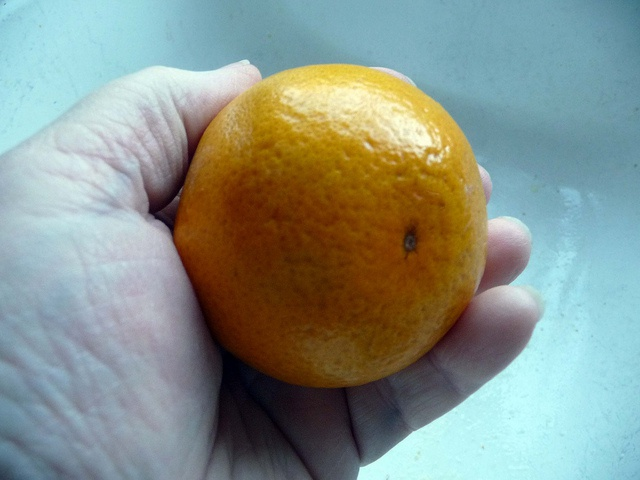Describe the objects in this image and their specific colors. I can see people in lightblue, darkgray, lightgray, black, and gray tones and orange in lightblue, maroon, olive, and khaki tones in this image. 